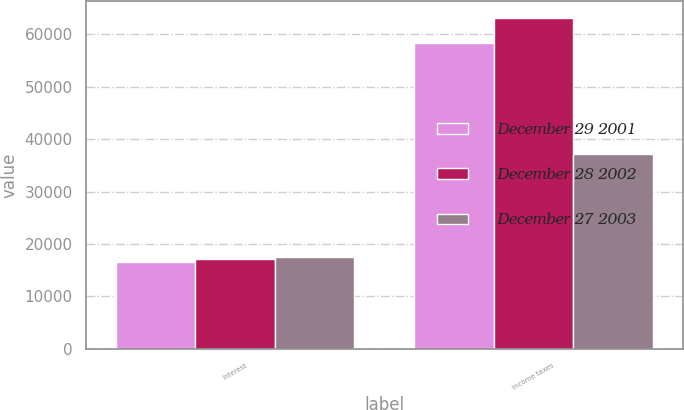Convert chart. <chart><loc_0><loc_0><loc_500><loc_500><stacked_bar_chart><ecel><fcel>Interest<fcel>Income taxes<nl><fcel>December 29 2001<fcel>16595<fcel>58405<nl><fcel>December 28 2002<fcel>17217<fcel>63196<nl><fcel>December 27 2003<fcel>17541<fcel>37222<nl></chart> 